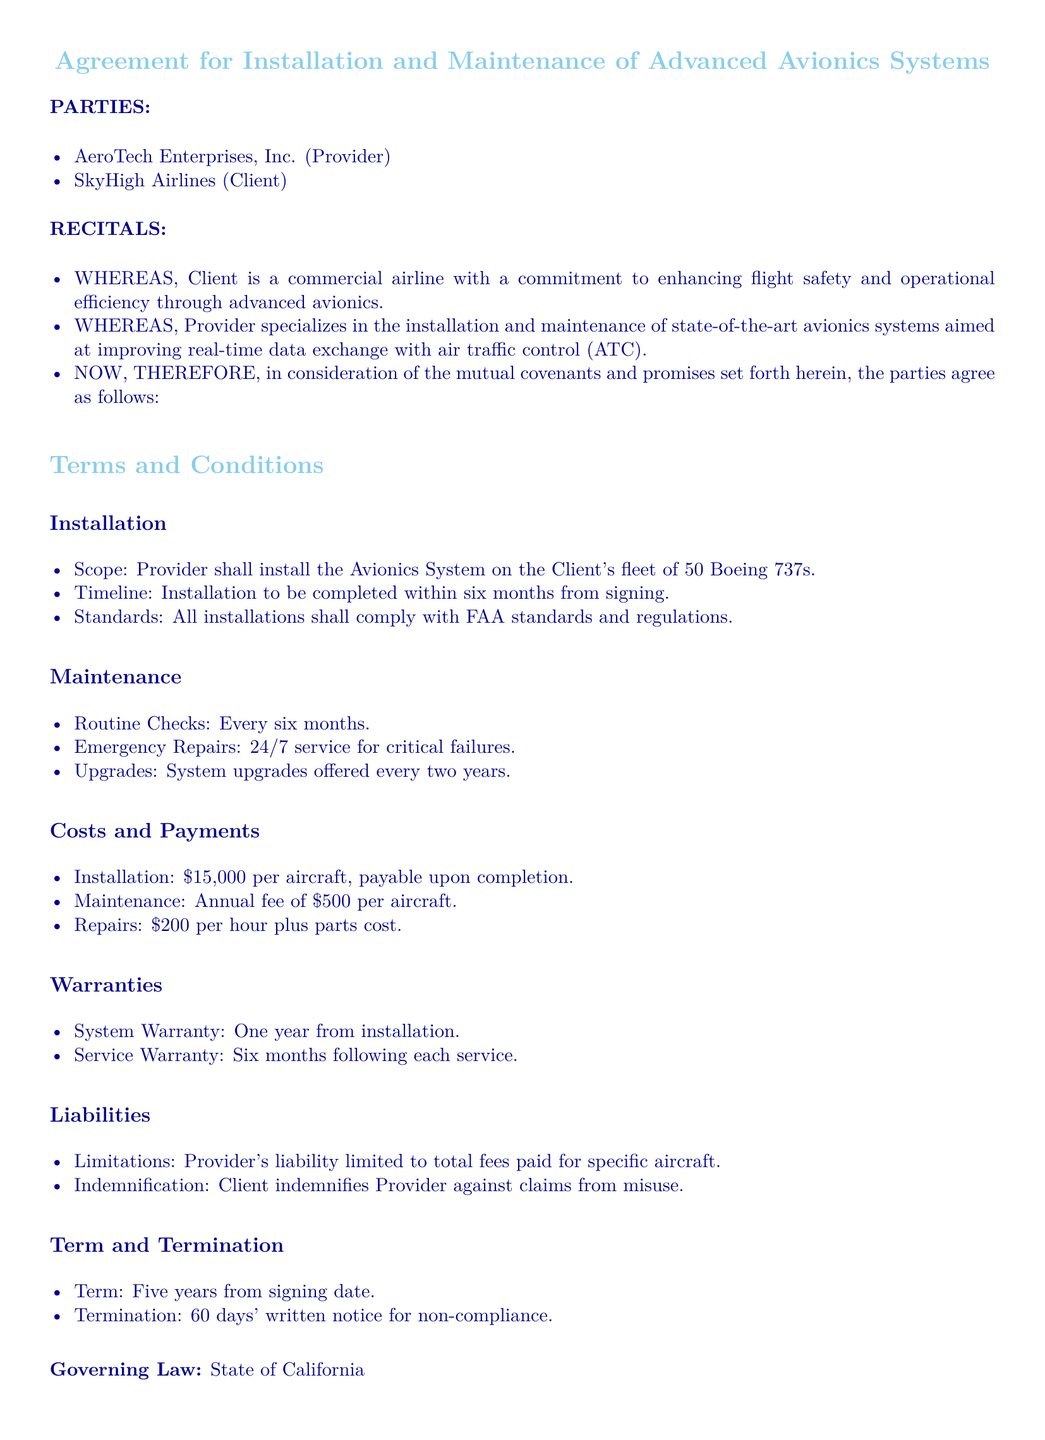what is the name of the provider? The provider named in the document is AeroTech Enterprises, Inc.
Answer: AeroTech Enterprises, Inc how many Boeing 737s will be installed with the avionics system? The document states that the avionics system will be installed on a fleet of 50 Boeing 737s.
Answer: 50 what is the installation cost per aircraft? The installation cost per aircraft is specified to be fifteen thousand dollars.
Answer: $15,000 how often will routine checks be conducted? Routine checks for the avionics system are scheduled to occur every six months.
Answer: every six months what is the warranty period for the system? The system warranty period is set for one year from installation.
Answer: one year how long is the term of the contract? The contract term is five years from the signing date.
Answer: five years what is the annual maintenance fee per aircraft? The annual maintenance fee stipulated in the document is five hundred dollars per aircraft.
Answer: $500 what kind of repairs does the contract cover? The contract specifies emergency repairs which are available 24/7 for critical failures.
Answer: emergency repairs what must the client provide to terminate the contract? To terminate the contract, the client must provide a sixty days' written notice for non-compliance.
Answer: sixty days' written notice 